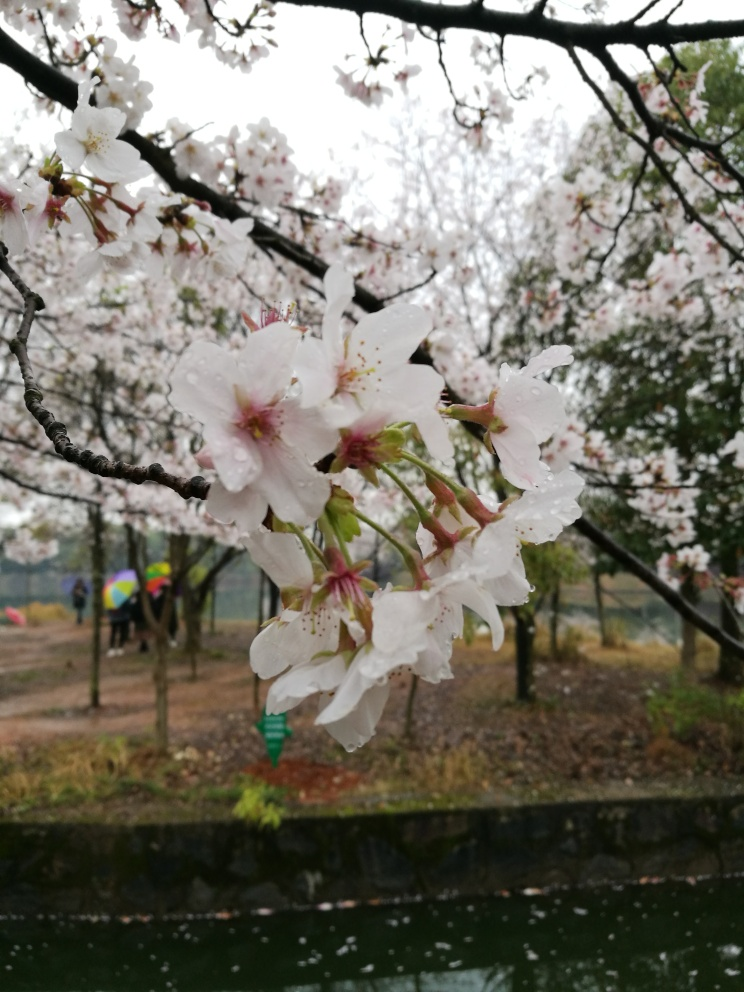What could improve the composition of this picture? Improving the composition could involve straightening the horizon line to enhance balance, adjusting the focus to make the background sharper, or repositioning the framing to adhere to the rule of thirds for a more dynamic image. 